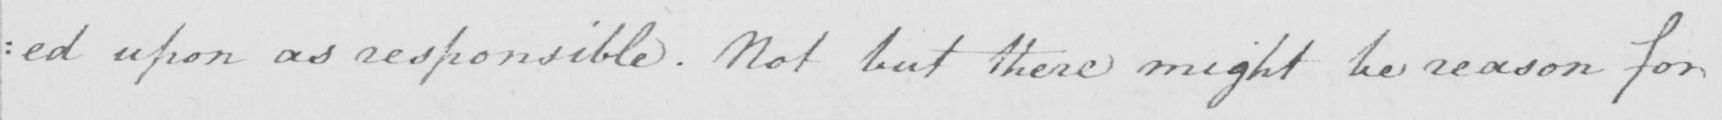Please transcribe the handwritten text in this image. : ed upon as responsible . Not but there might be reason for 